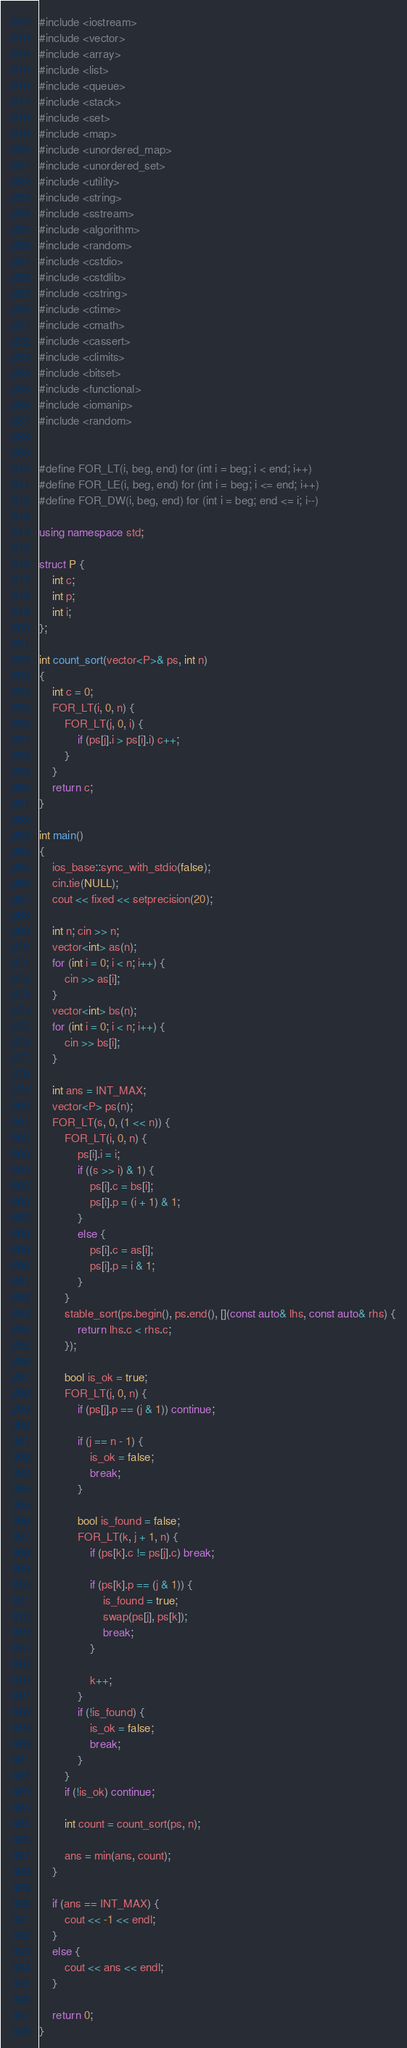<code> <loc_0><loc_0><loc_500><loc_500><_C++_>#include <iostream>
#include <vector>
#include <array>
#include <list>
#include <queue>
#include <stack>
#include <set>
#include <map>
#include <unordered_map>
#include <unordered_set>
#include <utility>
#include <string>
#include <sstream>
#include <algorithm>
#include <random>
#include <cstdio>
#include <cstdlib>
#include <cstring>
#include <ctime>
#include <cmath>
#include <cassert>
#include <climits>
#include <bitset>
#include <functional>
#include <iomanip>
#include <random>


#define FOR_LT(i, beg, end) for (int i = beg; i < end; i++)
#define FOR_LE(i, beg, end) for (int i = beg; i <= end; i++)
#define FOR_DW(i, beg, end) for (int i = beg; end <= i; i--)

using namespace std;

struct P {
	int c;
	int p;
	int i;
};

int count_sort(vector<P>& ps, int n)
{
	int c = 0;
	FOR_LT(i, 0, n) {
		FOR_LT(j, 0, i) {
			if (ps[j].i > ps[i].i) c++;
		}
	}
	return c;
}

int main()
{
	ios_base::sync_with_stdio(false);
	cin.tie(NULL);
	cout << fixed << setprecision(20);

	int n; cin >> n;
	vector<int> as(n);
	for (int i = 0; i < n; i++) {
		cin >> as[i];
	}
	vector<int> bs(n);
	for (int i = 0; i < n; i++) {
		cin >> bs[i];
	}

	int ans = INT_MAX;
	vector<P> ps(n);
	FOR_LT(s, 0, (1 << n)) {
		FOR_LT(i, 0, n) {
			ps[i].i = i;
			if ((s >> i) & 1) {
				ps[i].c = bs[i];
				ps[i].p = (i + 1) & 1;
			}
			else {
				ps[i].c = as[i];
				ps[i].p = i & 1;
			}
		}
		stable_sort(ps.begin(), ps.end(), [](const auto& lhs, const auto& rhs) {
			return lhs.c < rhs.c;
		});

		bool is_ok = true;
		FOR_LT(j, 0, n) {
			if (ps[j].p == (j & 1)) continue;

			if (j == n - 1) {
				is_ok = false;
				break;
			}

			bool is_found = false;
			FOR_LT(k, j + 1, n) {
				if (ps[k].c != ps[j].c) break;

				if (ps[k].p == (j & 1)) {
					is_found = true;
					swap(ps[j], ps[k]);
					break;
				}

				k++;
			}
			if (!is_found) {
				is_ok = false;
				break;
			}			
		}
		if (!is_ok) continue;

		int count = count_sort(ps, n);

		ans = min(ans, count);
	}

	if (ans == INT_MAX) {
		cout << -1 << endl;
	}
	else {
		cout << ans << endl;
	}

	return 0;
}</code> 